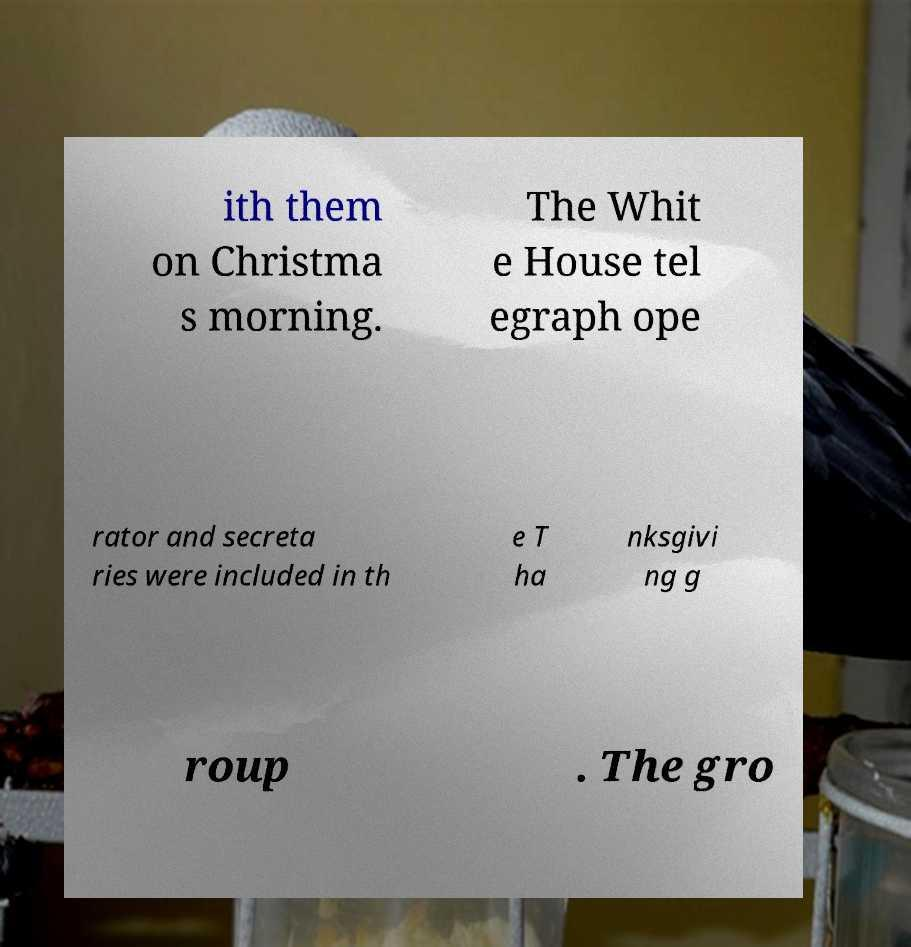Please identify and transcribe the text found in this image. ith them on Christma s morning. The Whit e House tel egraph ope rator and secreta ries were included in th e T ha nksgivi ng g roup . The gro 